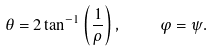Convert formula to latex. <formula><loc_0><loc_0><loc_500><loc_500>\theta = 2 \tan ^ { - 1 } \left ( \frac { 1 } { \rho } \right ) , \quad \varphi = \psi .</formula> 